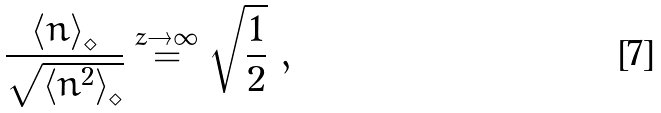Convert formula to latex. <formula><loc_0><loc_0><loc_500><loc_500>\frac { \left < n \right > _ { \diamond } } { \sqrt { \left < n ^ { 2 } \right > _ { \diamond } } } \overset { z \to \infty } { = } \sqrt { \frac { 1 } { 2 } } \ ,</formula> 